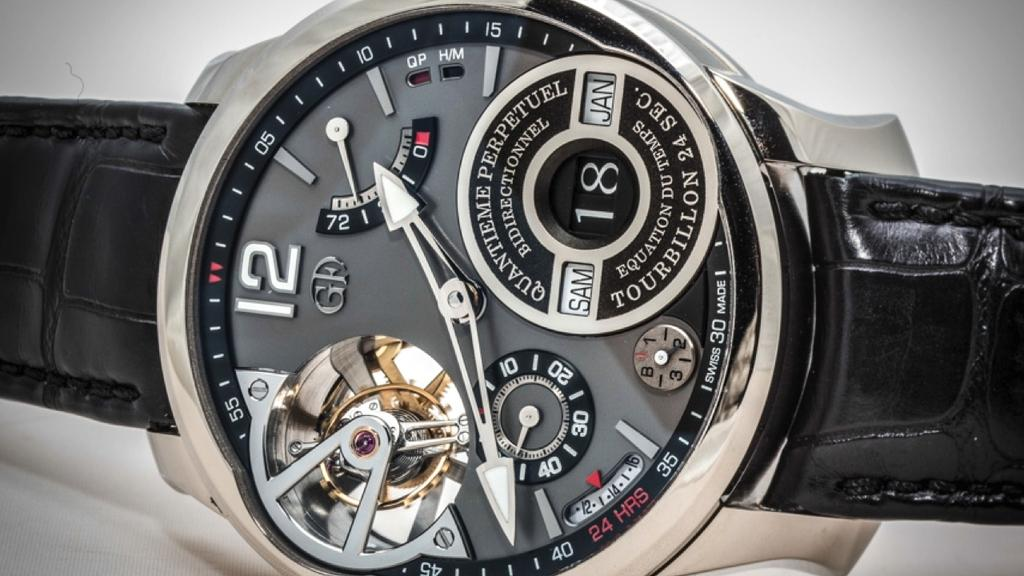Provide a one-sentence caption for the provided image. A watch with a black strap that indicates the time is 1:41. 